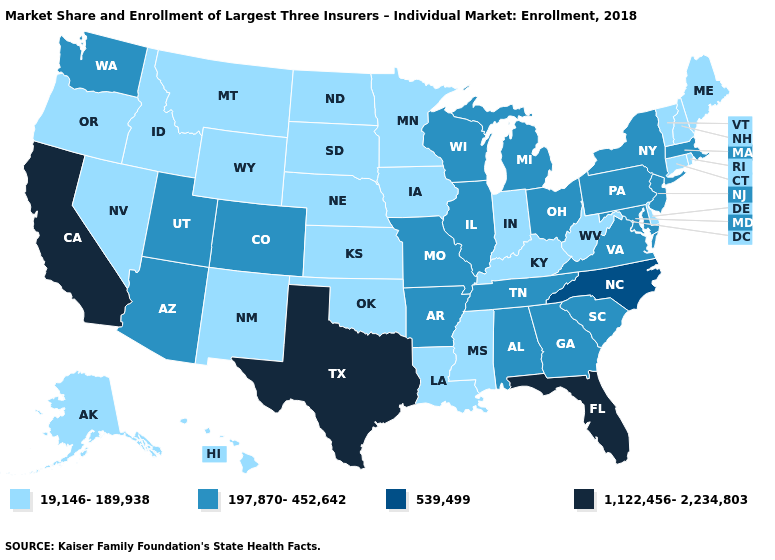What is the value of Louisiana?
Quick response, please. 19,146-189,938. Does South Carolina have a higher value than Wisconsin?
Write a very short answer. No. Does the first symbol in the legend represent the smallest category?
Write a very short answer. Yes. Which states have the lowest value in the South?
Short answer required. Delaware, Kentucky, Louisiana, Mississippi, Oklahoma, West Virginia. Which states have the lowest value in the MidWest?
Concise answer only. Indiana, Iowa, Kansas, Minnesota, Nebraska, North Dakota, South Dakota. Is the legend a continuous bar?
Keep it brief. No. Name the states that have a value in the range 1,122,456-2,234,803?
Be succinct. California, Florida, Texas. What is the highest value in states that border Washington?
Answer briefly. 19,146-189,938. What is the highest value in states that border Maine?
Answer briefly. 19,146-189,938. What is the value of Ohio?
Short answer required. 197,870-452,642. Does Alaska have the same value as Indiana?
Write a very short answer. Yes. Does the first symbol in the legend represent the smallest category?
Concise answer only. Yes. Does New York have the highest value in the Northeast?
Keep it brief. Yes. Name the states that have a value in the range 539,499?
Quick response, please. North Carolina. 